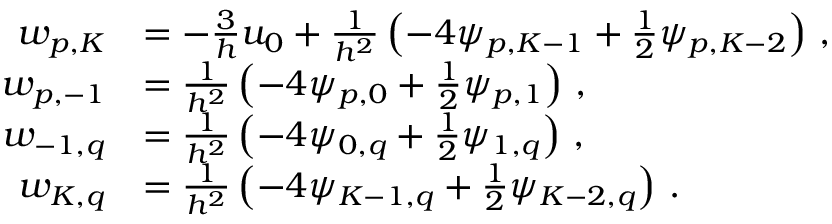Convert formula to latex. <formula><loc_0><loc_0><loc_500><loc_500>\begin{array} { r l } { w _ { p , K } } & { = - \frac { 3 } { h } u _ { 0 } + \frac { 1 } { h ^ { 2 } } \left ( - 4 \psi _ { p , K - 1 } + \frac { 1 } { 2 } \psi _ { p , K - 2 } \right ) \, , } \\ { w _ { p , - 1 } } & { = \frac { 1 } { h ^ { 2 } } \left ( - 4 \psi _ { p , 0 } + \frac { 1 } { 2 } \psi _ { p , 1 } \right ) \, , } \\ { w _ { - 1 , q } } & { = \frac { 1 } { h ^ { 2 } } \left ( - 4 \psi _ { 0 , q } + \frac { 1 } { 2 } \psi _ { 1 , q } \right ) \, , } \\ { w _ { K , q } } & { = \frac { 1 } { h ^ { 2 } } \left ( - 4 \psi _ { K - 1 , q } + \frac { 1 } { 2 } \psi _ { K - 2 , q } \right ) \, . } \end{array}</formula> 